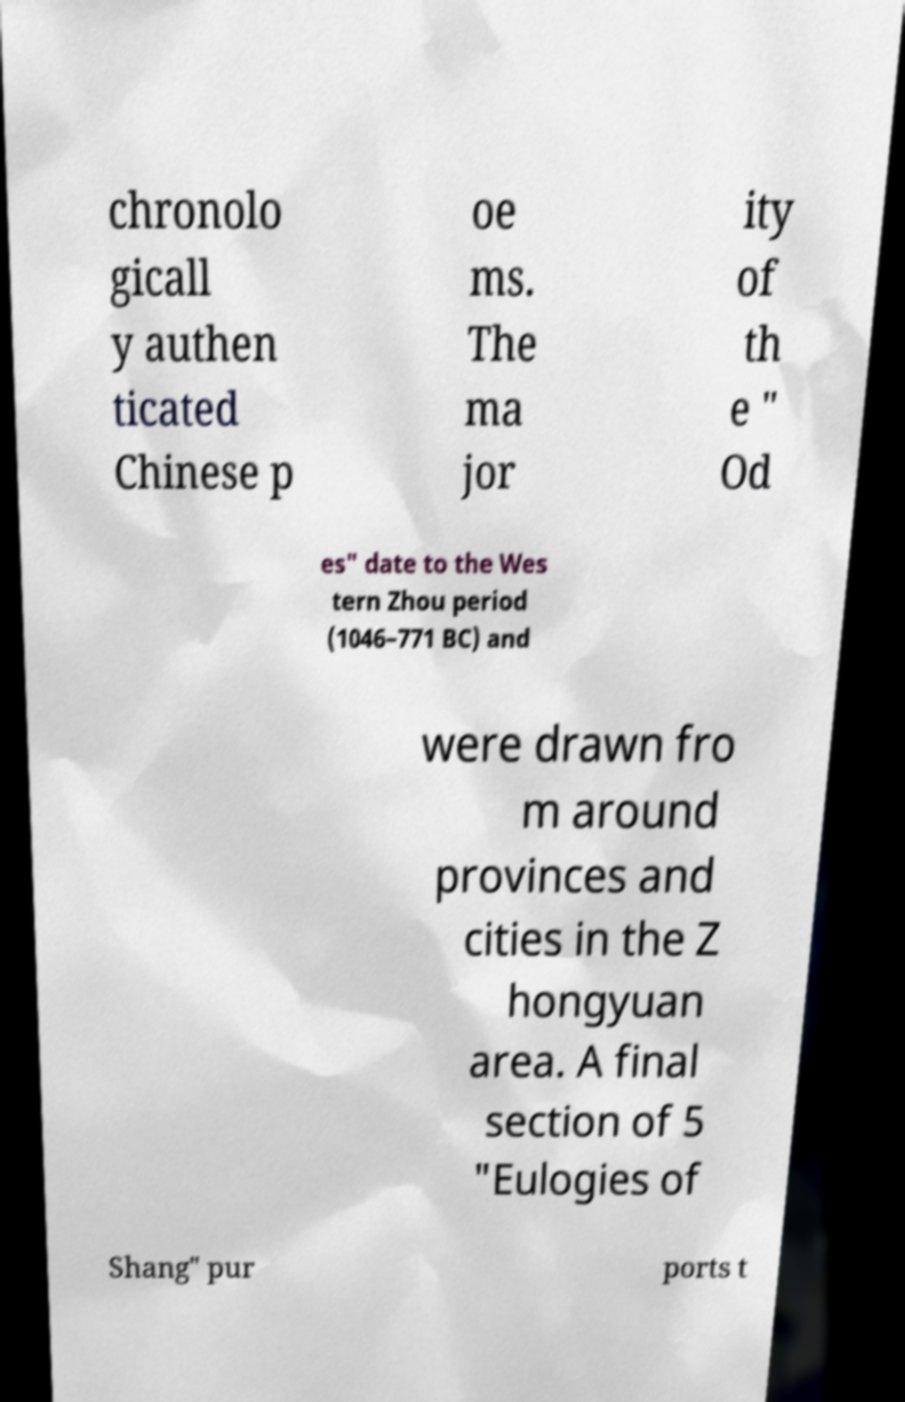What messages or text are displayed in this image? I need them in a readable, typed format. chronolo gicall y authen ticated Chinese p oe ms. The ma jor ity of th e " Od es" date to the Wes tern Zhou period (1046–771 BC) and were drawn fro m around provinces and cities in the Z hongyuan area. A final section of 5 "Eulogies of Shang" pur ports t 